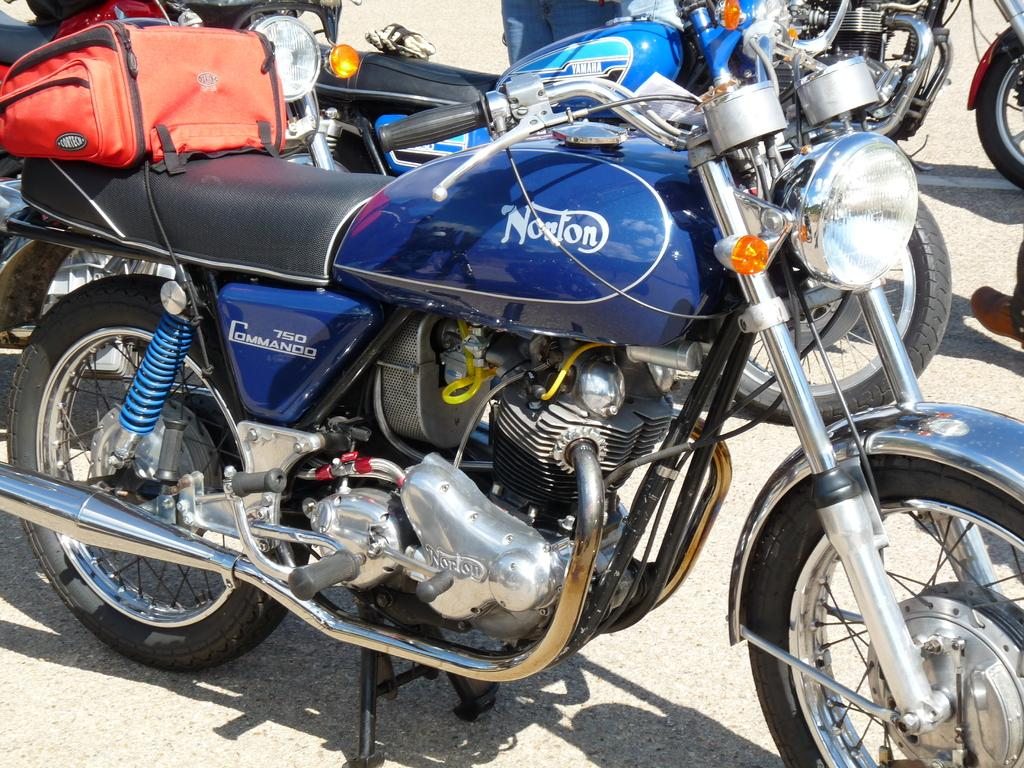What color is the motorbike in the image? The motorbike in the image is blue. What additional feature is present on the motorbike? The motorbike has a bag on it. Can you describe the background of the image? There are more motorbikes visible in the background of the image. How many eyes does the motorbike have in the image? Motorbikes do not have eyes, as they are inanimate objects. 